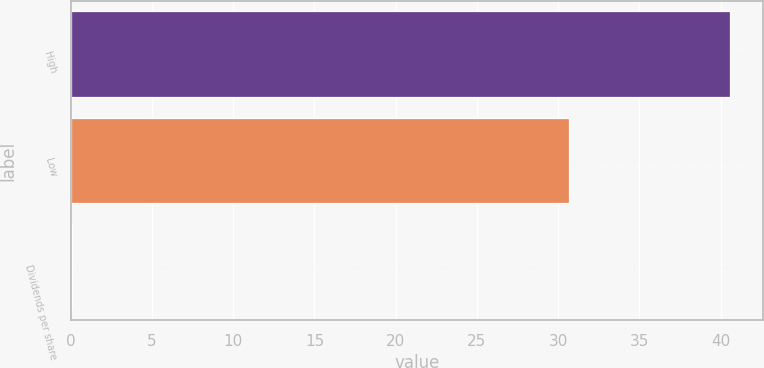Convert chart. <chart><loc_0><loc_0><loc_500><loc_500><bar_chart><fcel>High<fcel>Low<fcel>Dividends per share<nl><fcel>40.56<fcel>30.67<fcel>0.07<nl></chart> 